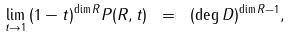Convert formula to latex. <formula><loc_0><loc_0><loc_500><loc_500>\lim _ { t \to 1 } \, ( 1 - t ) ^ { \dim R } P ( R , t ) \ = \ ( \deg D ) ^ { \dim R - 1 } ,</formula> 